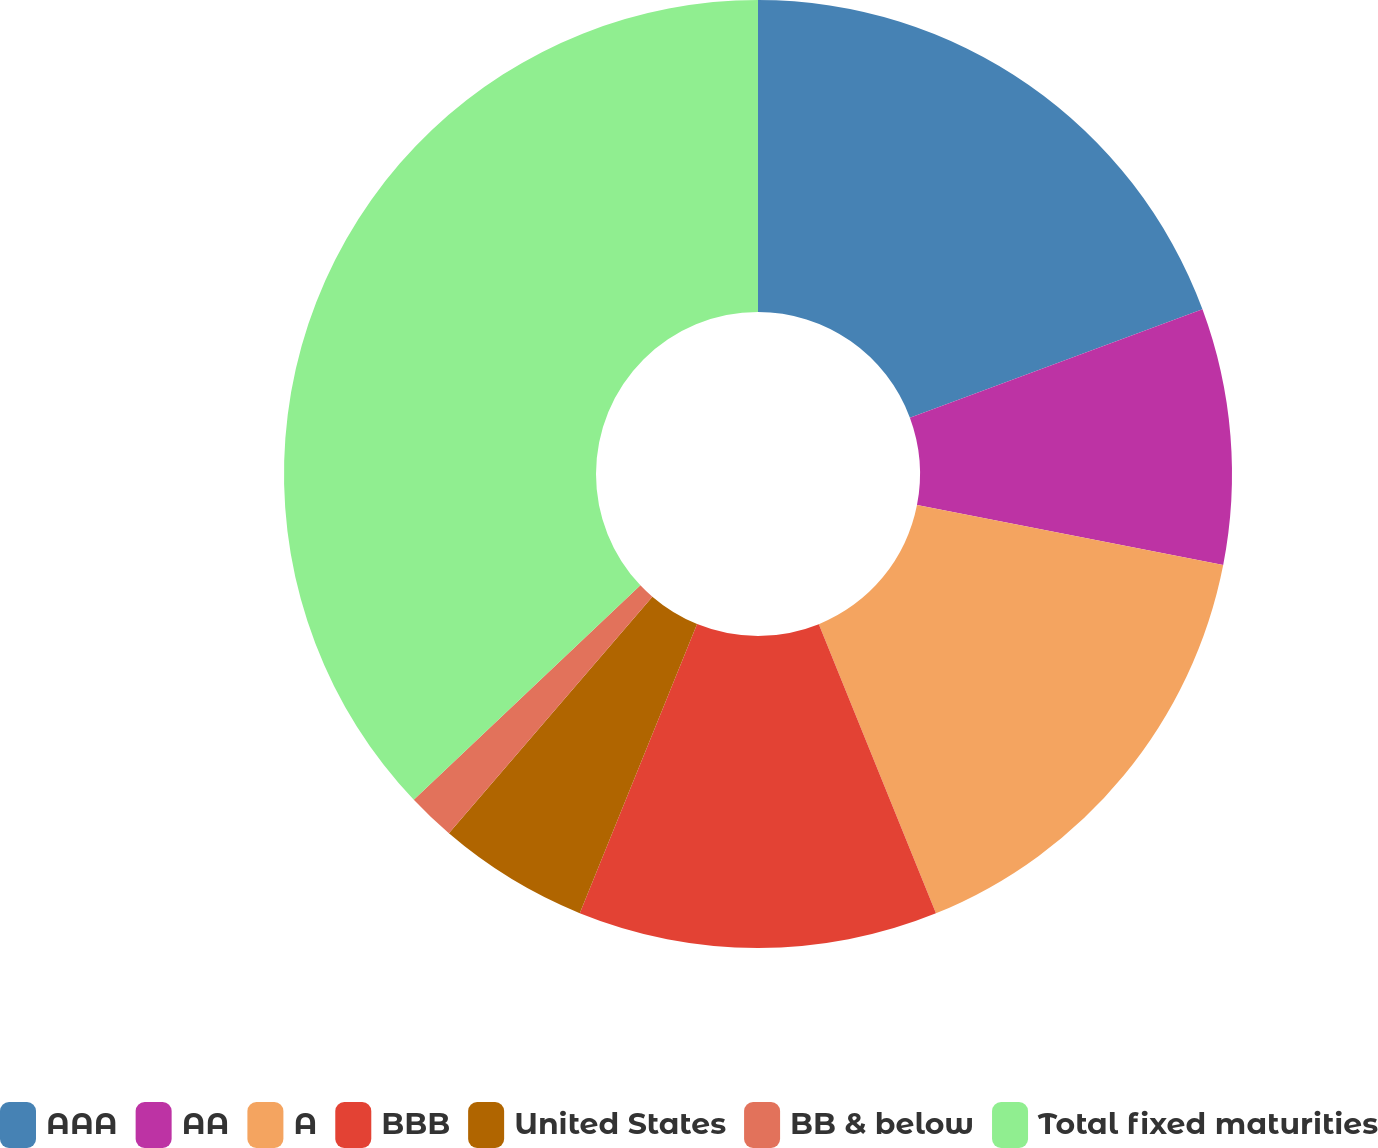<chart> <loc_0><loc_0><loc_500><loc_500><pie_chart><fcel>AAA<fcel>AA<fcel>A<fcel>BBB<fcel>United States<fcel>BB & below<fcel>Total fixed maturities<nl><fcel>19.35%<fcel>8.72%<fcel>15.8%<fcel>12.26%<fcel>5.17%<fcel>1.63%<fcel>37.06%<nl></chart> 